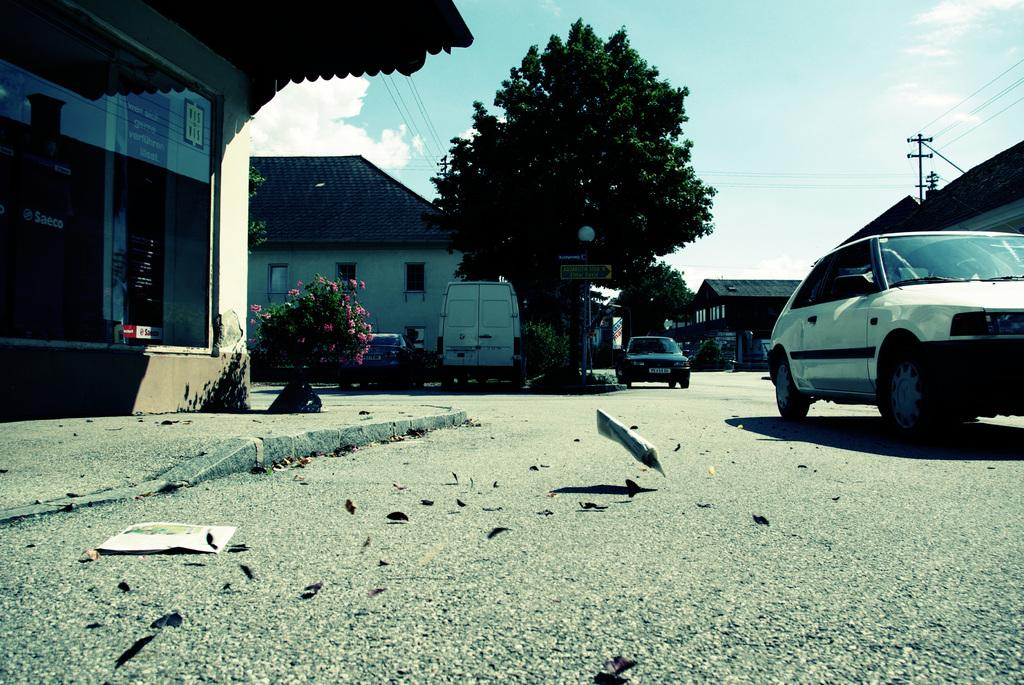What type of structures can be seen in the image? There are houses in the image. What else can be found in the image besides houses? There are trees, poles, vehicles, and things on the ground in the image. How many oranges are hanging from the trees in the image? There are no oranges present in the image; it only features trees without any fruit. What type of error can be seen in the image? There is no error present in the image; it is a clear and accurate representation of the scene. 